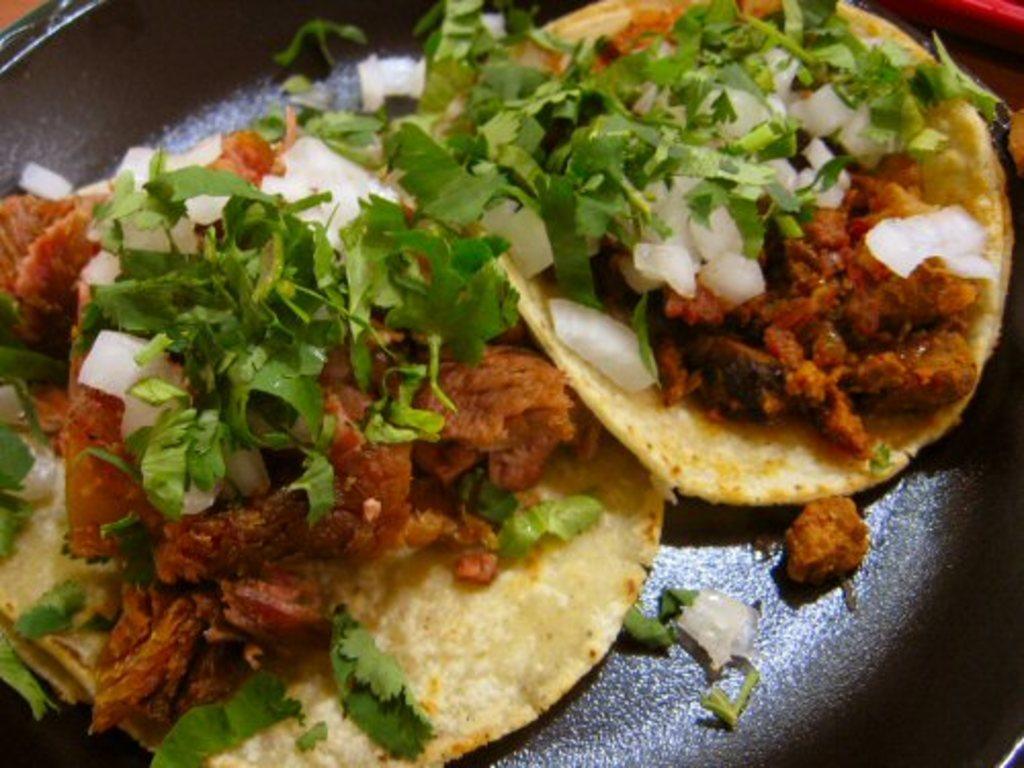In one or two sentences, can you explain what this image depicts? Here we can see two same food items on a platform. 